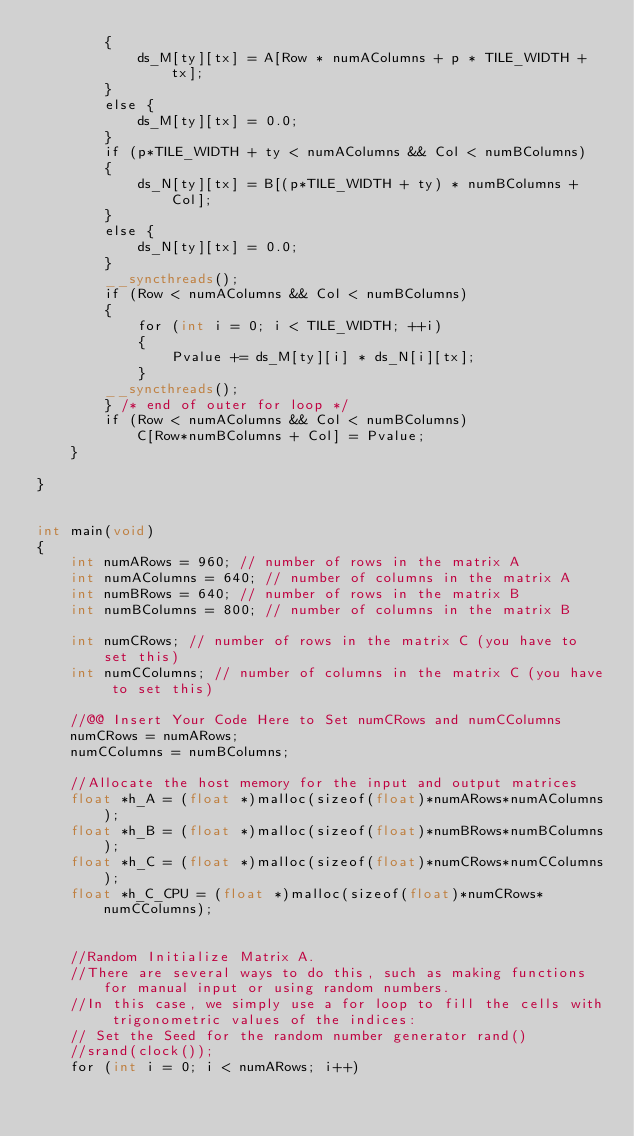Convert code to text. <code><loc_0><loc_0><loc_500><loc_500><_Cuda_>		{
			ds_M[ty][tx] = A[Row * numAColumns + p * TILE_WIDTH + tx];
		}
		else {
			ds_M[ty][tx] = 0.0;
		}
		if (p*TILE_WIDTH + ty < numAColumns && Col < numBColumns)
		{
			ds_N[ty][tx] = B[(p*TILE_WIDTH + ty) * numBColumns + Col];
		}
		else {
			ds_N[ty][tx] = 0.0;
		}
		__syncthreads();
		if (Row < numAColumns && Col < numBColumns)
		{
			for (int i = 0; i < TILE_WIDTH; ++i)
			{
				Pvalue += ds_M[ty][i] * ds_N[i][tx];
			}
		__syncthreads();
		} /* end of outer for loop */
		if (Row < numAColumns && Col < numBColumns)
			C[Row*numBColumns + Col] = Pvalue;
	}
	
}


int main(void)
{
	int numARows = 960; // number of rows in the matrix A
	int numAColumns = 640; // number of columns in the matrix A
	int numBRows = 640; // number of rows in the matrix B
	int numBColumns = 800; // number of columns in the matrix B

	int numCRows; // number of rows in the matrix C (you have to set this)
	int numCColumns; // number of columns in the matrix C (you have to set this)

	//@@ Insert Your Code Here to Set numCRows and numCColumns
	numCRows = numARows;
	numCColumns = numBColumns;

	//Allocate the host memory for the input and output matrices
	float *h_A = (float *)malloc(sizeof(float)*numARows*numAColumns);
	float *h_B = (float *)malloc(sizeof(float)*numBRows*numBColumns);
	float *h_C = (float *)malloc(sizeof(float)*numCRows*numCColumns);
	float *h_C_CPU = (float *)malloc(sizeof(float)*numCRows*numCColumns);


	//Random Initialize Matrix A. 
	//There are several ways to do this, such as making functions for manual input or using random numbers. 
	//In this case, we simply use a for loop to fill the cells with trigonometric values of the indices:
	// Set the Seed for the random number generator rand() 
	//srand(clock());
	for (int i = 0; i < numARows; i++)</code> 